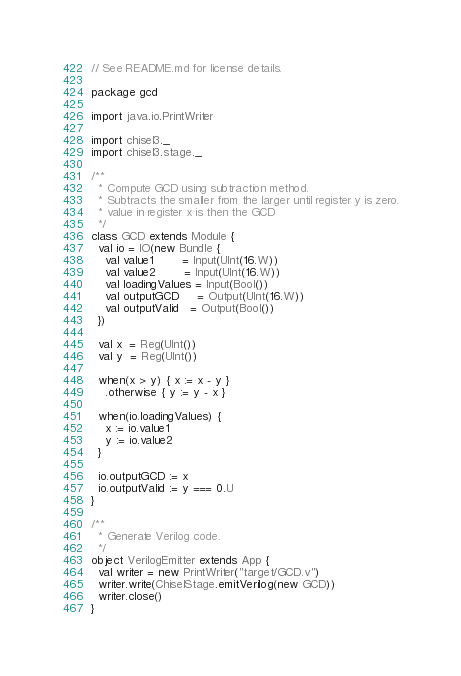<code> <loc_0><loc_0><loc_500><loc_500><_Scala_>// See README.md for license details.

package gcd

import java.io.PrintWriter

import chisel3._
import chisel3.stage._

/**
  * Compute GCD using subtraction method.
  * Subtracts the smaller from the larger until register y is zero.
  * value in register x is then the GCD
  */
class GCD extends Module {
  val io = IO(new Bundle {
    val value1        = Input(UInt(16.W))
    val value2        = Input(UInt(16.W))
    val loadingValues = Input(Bool())
    val outputGCD     = Output(UInt(16.W))
    val outputValid   = Output(Bool())
  })

  val x  = Reg(UInt())
  val y  = Reg(UInt())

  when(x > y) { x := x - y }
    .otherwise { y := y - x }

  when(io.loadingValues) {
    x := io.value1
    y := io.value2
  }

  io.outputGCD := x
  io.outputValid := y === 0.U
}

/**
  * Generate Verilog code.
  */
object VerilogEmitter extends App {
  val writer = new PrintWriter("target/GCD.v")
  writer.write(ChiselStage.emitVerilog(new GCD))
  writer.close()
}
</code> 